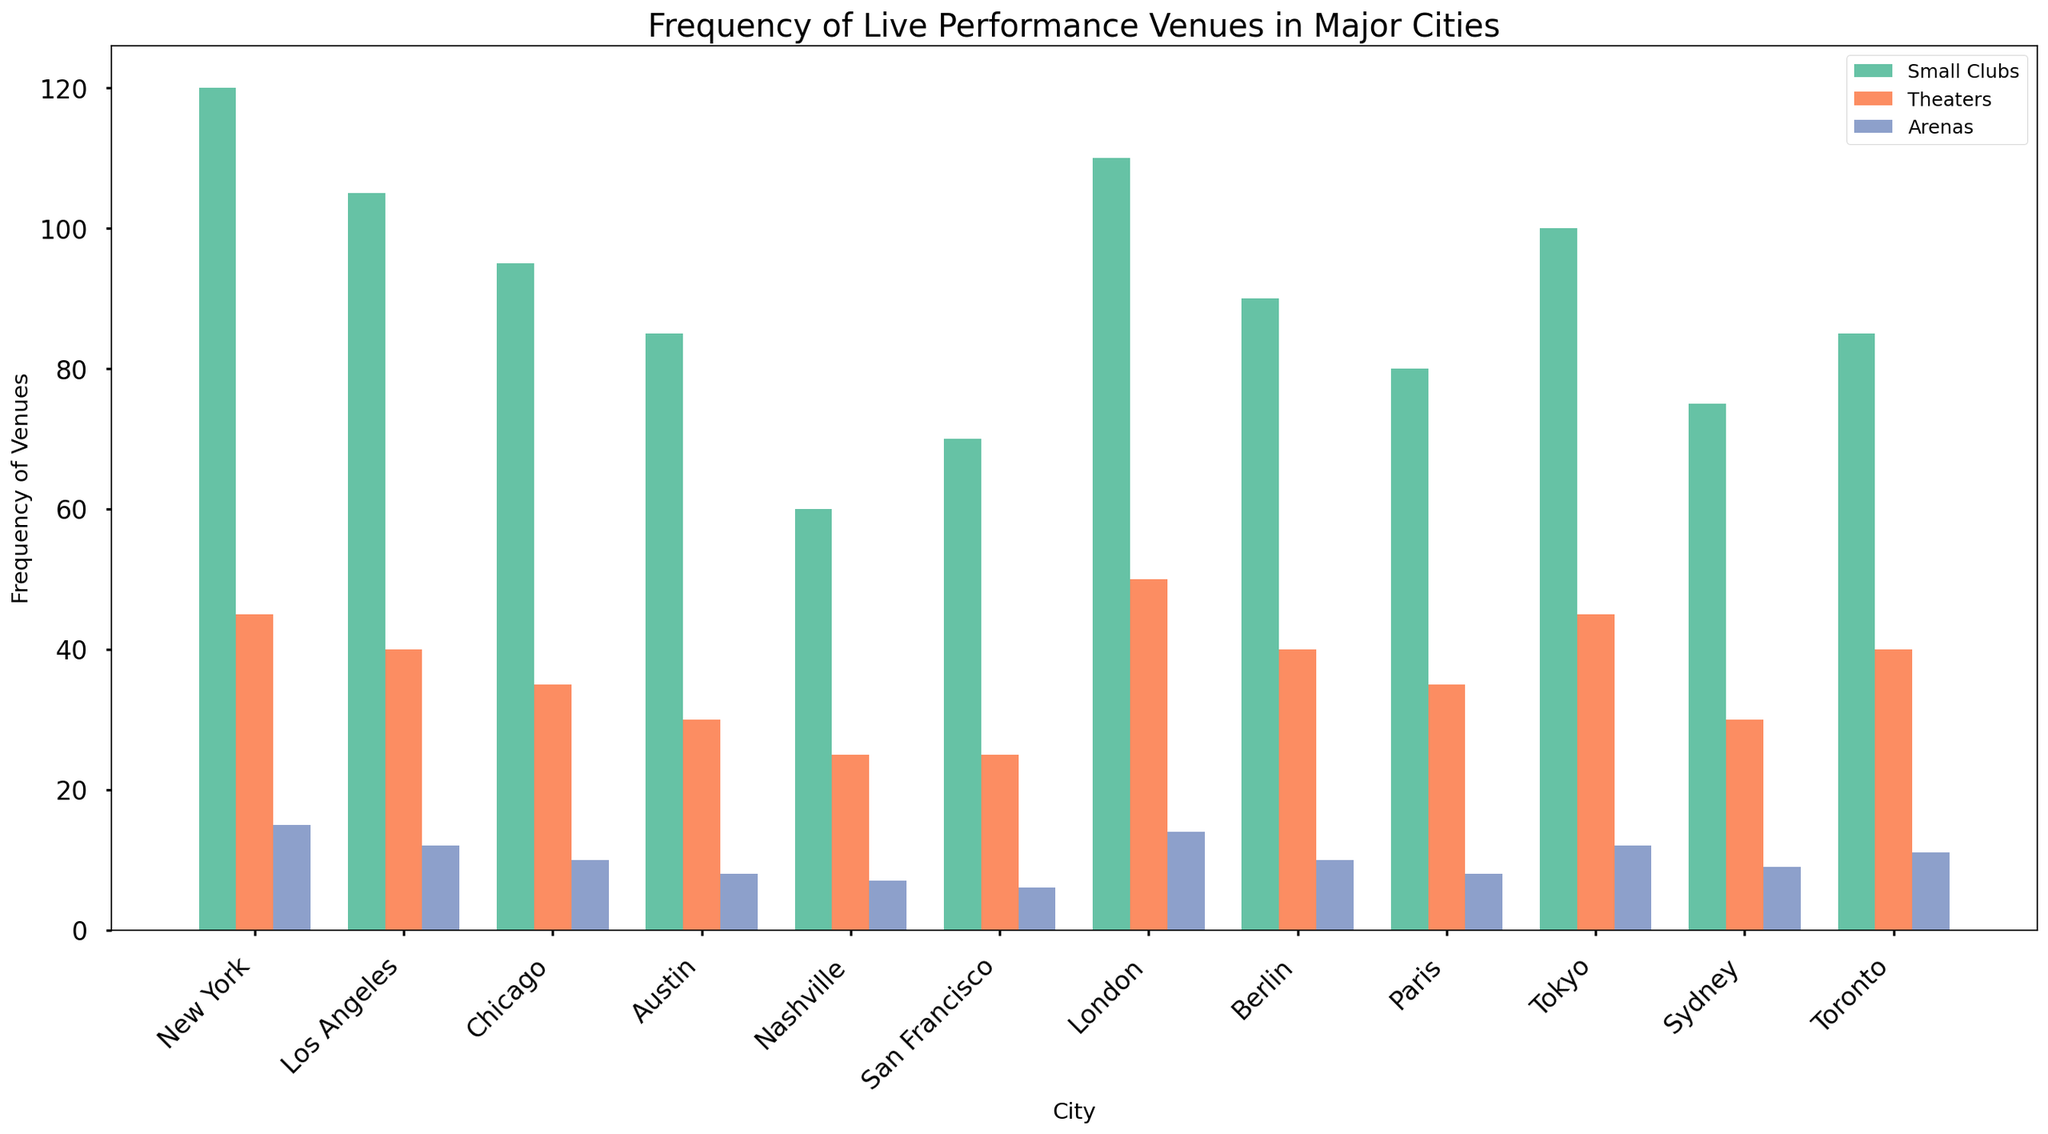What city has the highest number of small clubs? Look at the bar heights for small clubs across all cities. The tallest bar represents New York, which has 120 small clubs.
Answer: New York How many more small clubs are there in New York compared to Berlin? New York has 120 small clubs and Berlin has 90 small clubs. The difference is 120 - 90 = 30.
Answer: 30 Which city has more theaters: Paris or Nashville? Compare the height of the theater bars for Paris and Nashville. Paris has 35 theaters while Nashville has 25 theaters.
Answer: Paris What is the total number of arenas in Chicago and Sydney combined? Chicago has 10 arenas and Sydney has 9 arenas. The total is 10 + 9 = 19.
Answer: 19 Which category has the least variation in frequency across all cities? Observe the height differences among the bars in the chart. Arenas generally show the smallest variation in heights compared to small clubs and theaters.
Answer: Arenas What is the average number of theaters in the given cities? Sum the number of theaters across all cities (45 + 40 + 35 + 30 + 25 + 25 + 50 + 40 + 35 + 45 + 30 + 40 = 440) and divide by the number of cities (12). The average is 440 / 12 ≈ 36.67.
Answer: 36.67 Which city has the lowest number of arenas? Observe the bars for arenas. San Francisco has the shortest bar for arenas, with only 6 arenas.
Answer: San Francisco How many small clubs are there in Tokyo compared to Austin? Tokyo has 100 small clubs while Austin has 85 small clubs.
Answer: 100, 85 What is the sum of small clubs and theaters in Los Angeles? Los Angeles has 105 small clubs and 40 theaters. The sum is 105 + 40 = 145.
Answer: 145 Are there more theaters in London or arenas in New York? London has 50 theaters and New York has 15 arenas. London has more theaters.
Answer: London 